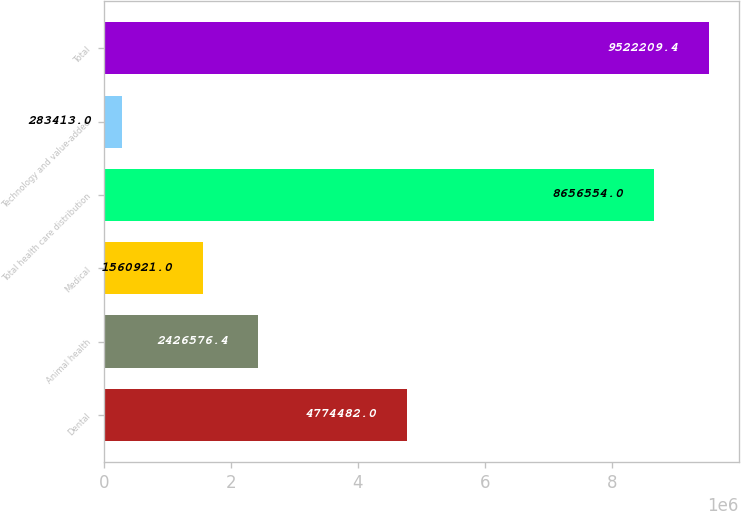Convert chart. <chart><loc_0><loc_0><loc_500><loc_500><bar_chart><fcel>Dental<fcel>Animal health<fcel>Medical<fcel>Total health care distribution<fcel>Technology and value-added<fcel>Total<nl><fcel>4.77448e+06<fcel>2.42658e+06<fcel>1.56092e+06<fcel>8.65655e+06<fcel>283413<fcel>9.52221e+06<nl></chart> 